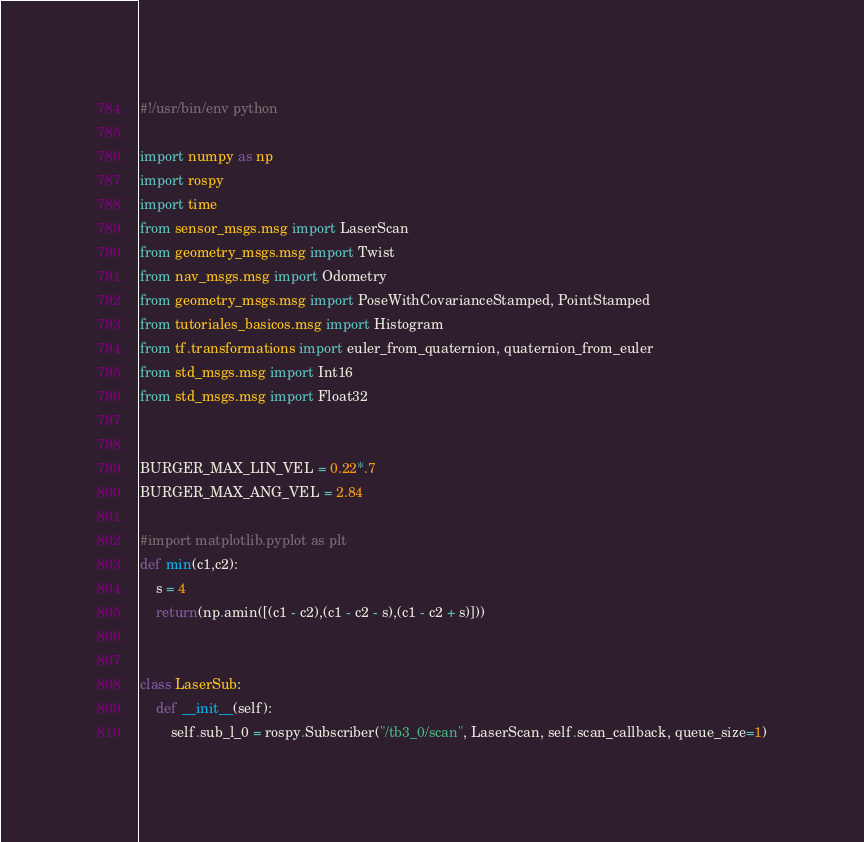Convert code to text. <code><loc_0><loc_0><loc_500><loc_500><_Python_>#!/usr/bin/env python

import numpy as np
import rospy
import time
from sensor_msgs.msg import LaserScan
from geometry_msgs.msg import Twist
from nav_msgs.msg import Odometry
from geometry_msgs.msg import PoseWithCovarianceStamped, PointStamped
from tutoriales_basicos.msg import Histogram
from tf.transformations import euler_from_quaternion, quaternion_from_euler
from std_msgs.msg import Int16
from std_msgs.msg import Float32


BURGER_MAX_LIN_VEL = 0.22*.7
BURGER_MAX_ANG_VEL = 2.84

#import matplotlib.pyplot as plt
def min(c1,c2):
    s = 4
    return(np.amin([(c1 - c2),(c1 - c2 - s),(c1 - c2 + s)]))


class LaserSub:
    def __init__(self):
        self.sub_l_0 = rospy.Subscriber("/tb3_0/scan", LaserScan, self.scan_callback, queue_size=1)</code> 